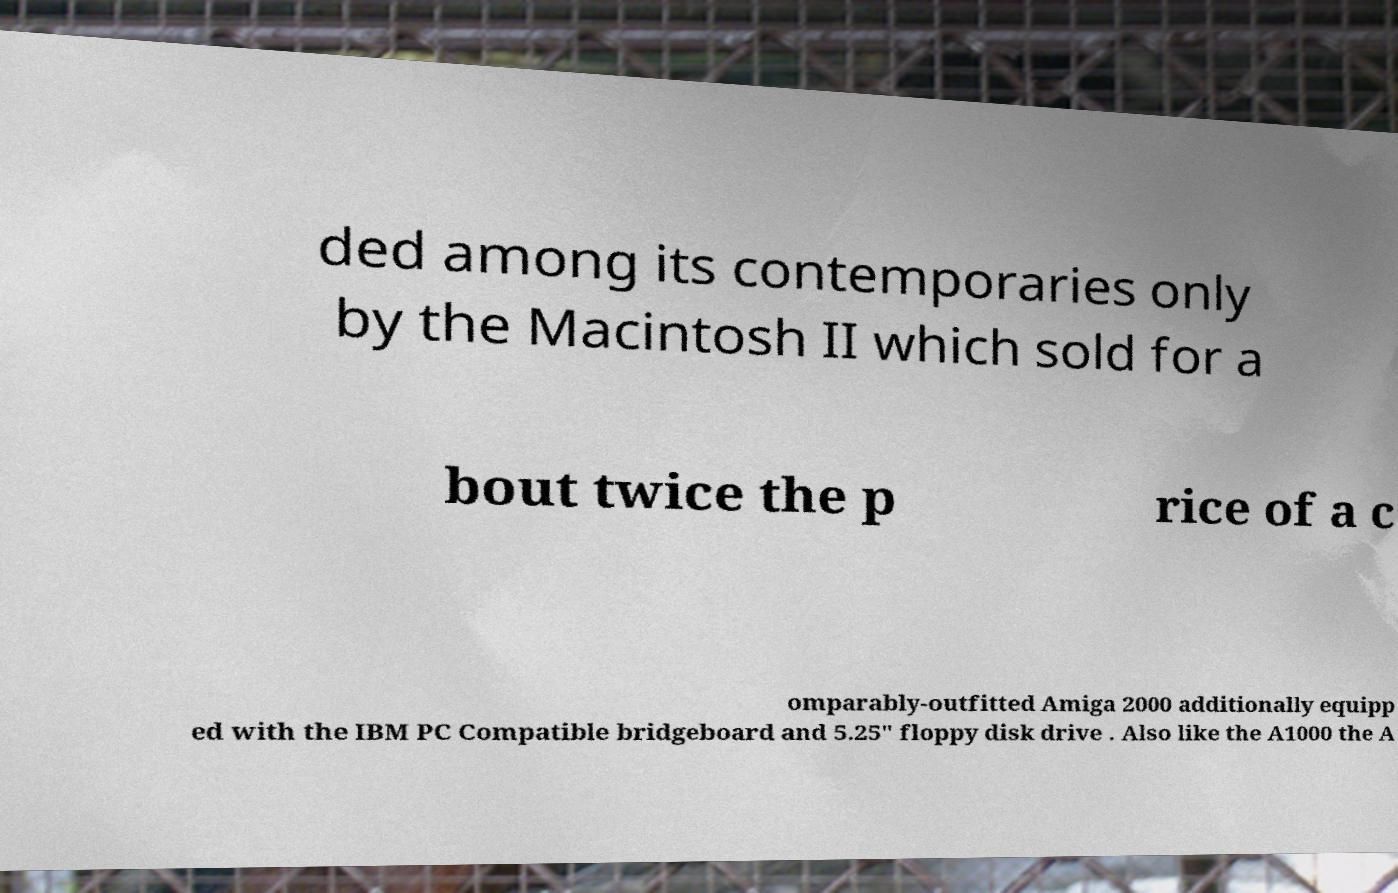Can you read and provide the text displayed in the image?This photo seems to have some interesting text. Can you extract and type it out for me? ded among its contemporaries only by the Macintosh II which sold for a bout twice the p rice of a c omparably-outfitted Amiga 2000 additionally equipp ed with the IBM PC Compatible bridgeboard and 5.25" floppy disk drive . Also like the A1000 the A 